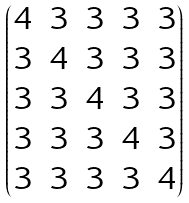<formula> <loc_0><loc_0><loc_500><loc_500>\begin{pmatrix} 4 & 3 & 3 & 3 & 3 \\ 3 & 4 & 3 & 3 & 3 \\ 3 & 3 & 4 & 3 & 3 \\ 3 & 3 & 3 & 4 & 3 \\ 3 & 3 & 3 & 3 & 4 \end{pmatrix}</formula> 